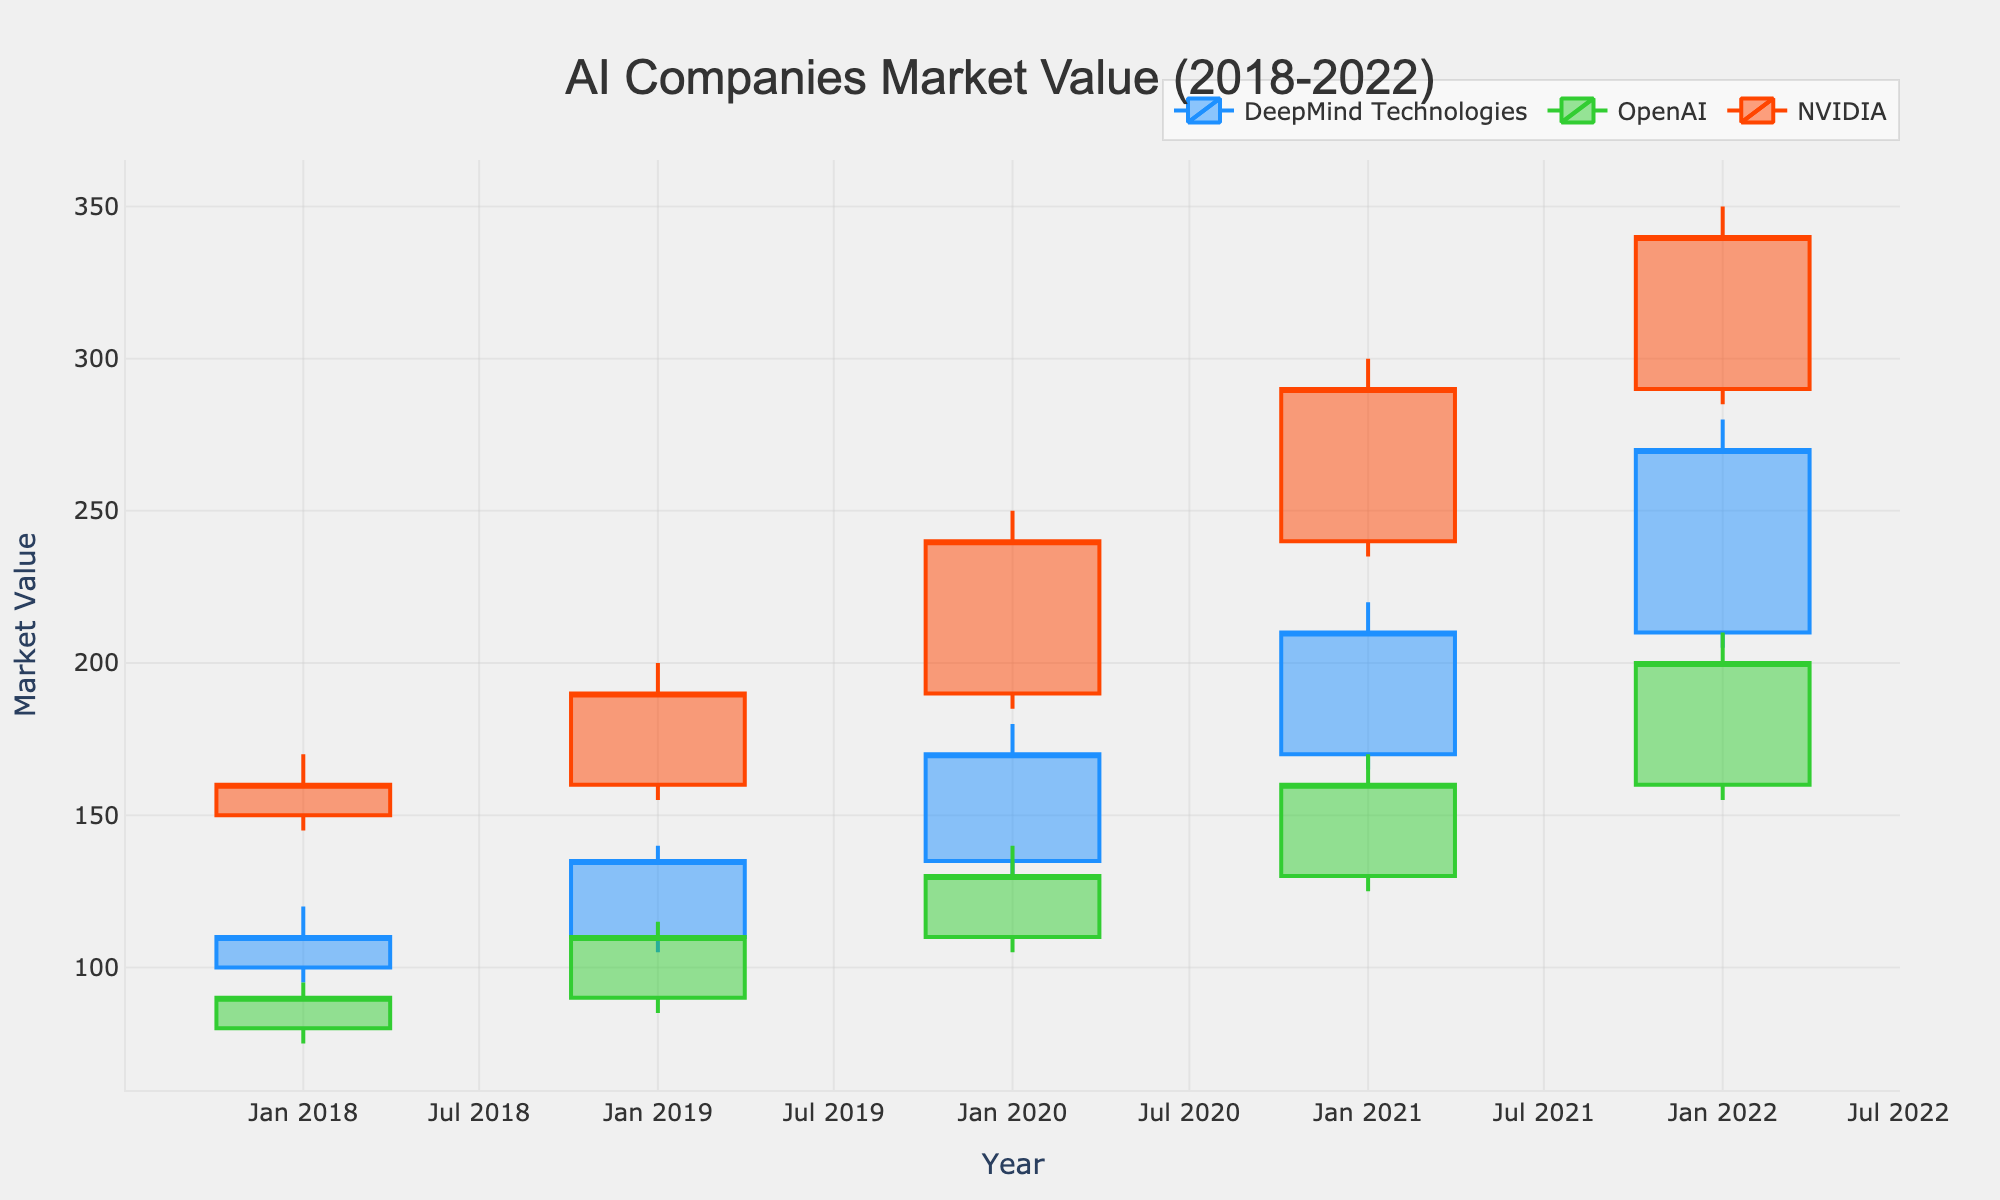what is the title of the chart? The title is displayed at the top of the chart in a prominent font for easy identification. In this chart, it appears as "AI Companies Market Value (2018-2022)".
Answer: AI Companies Market Value (2018-2022) How many companies are tracked in this chart? By looking at the legend or identifying the distinct colors and labels within the chart, you can see three companies are tracked: DeepMind Technologies, OpenAI, and NVIDIA.
Answer: 3 Which company had the highest closing value in 2019? By examining the candlestick tops for each company in 2019, we see NVIDIA had the highest closing value, indicated by the top line of its candle in 2019.
Answer: NVIDIA What is the overall trend of DeepMind Technologies from 2018 to 2022? Observing the candlestick positions, we can see that DeepMind Technologies' closing values increased steadily from 110 in 2018 to 270 in 2022, indicating an upward trend.
Answer: Upward Compare the low values of OpenAI in 2019 and 2020. Which year had a lower value? Reviewing the bottom line of the candlestick for each year shows that 2020 had a low value of 105 compared to the low value of 85 in 2019.
Answer: 2019 What was the opening value of NVIDIA in 2021 and how did it compare to its closing value in 2020? Referring to NVIDIA's candlestick sections for 2020 and 2021 shows an opening value of 240 in 2021, higher than the closing value of 240 in 2020.
Answer: Higher Which company showed the most significant increase in its closing value from 2021 to 2022? By analyzing the candlesticks, NVIDIA's closing value rose from 290 in 2021 to 340 in 2022, a substantial increase compared to DeepMind's and OpenAI's increases.
Answer: NVIDIA For which years did OpenAI show an increasing trend in closing values? Reviewing OpenAI's candlesticks, it shows increasing trends in closing values from 2018 to 2019 and from 2019 to 2020, as well as from 2021 to 2022.
Answer: 2018 to 2019, 2019 to 2020, and 2021 to 2022 What was the range of the high and low values for DeepMind Technologies in 2020? Examining DeepMind Technologies' candlestick for 2020, the highest value was 180 and the lowest was 130. Therefore, the range is computed as 180 - 130 = 50.
Answer: 50 Out of all the companies, which had the lowest opening value throughout the observed years and when? By checking the lowest opening values for each year and company, OpenAI had the lowest opening value of 80 in 2018.
Answer: OpenAI in 2018 